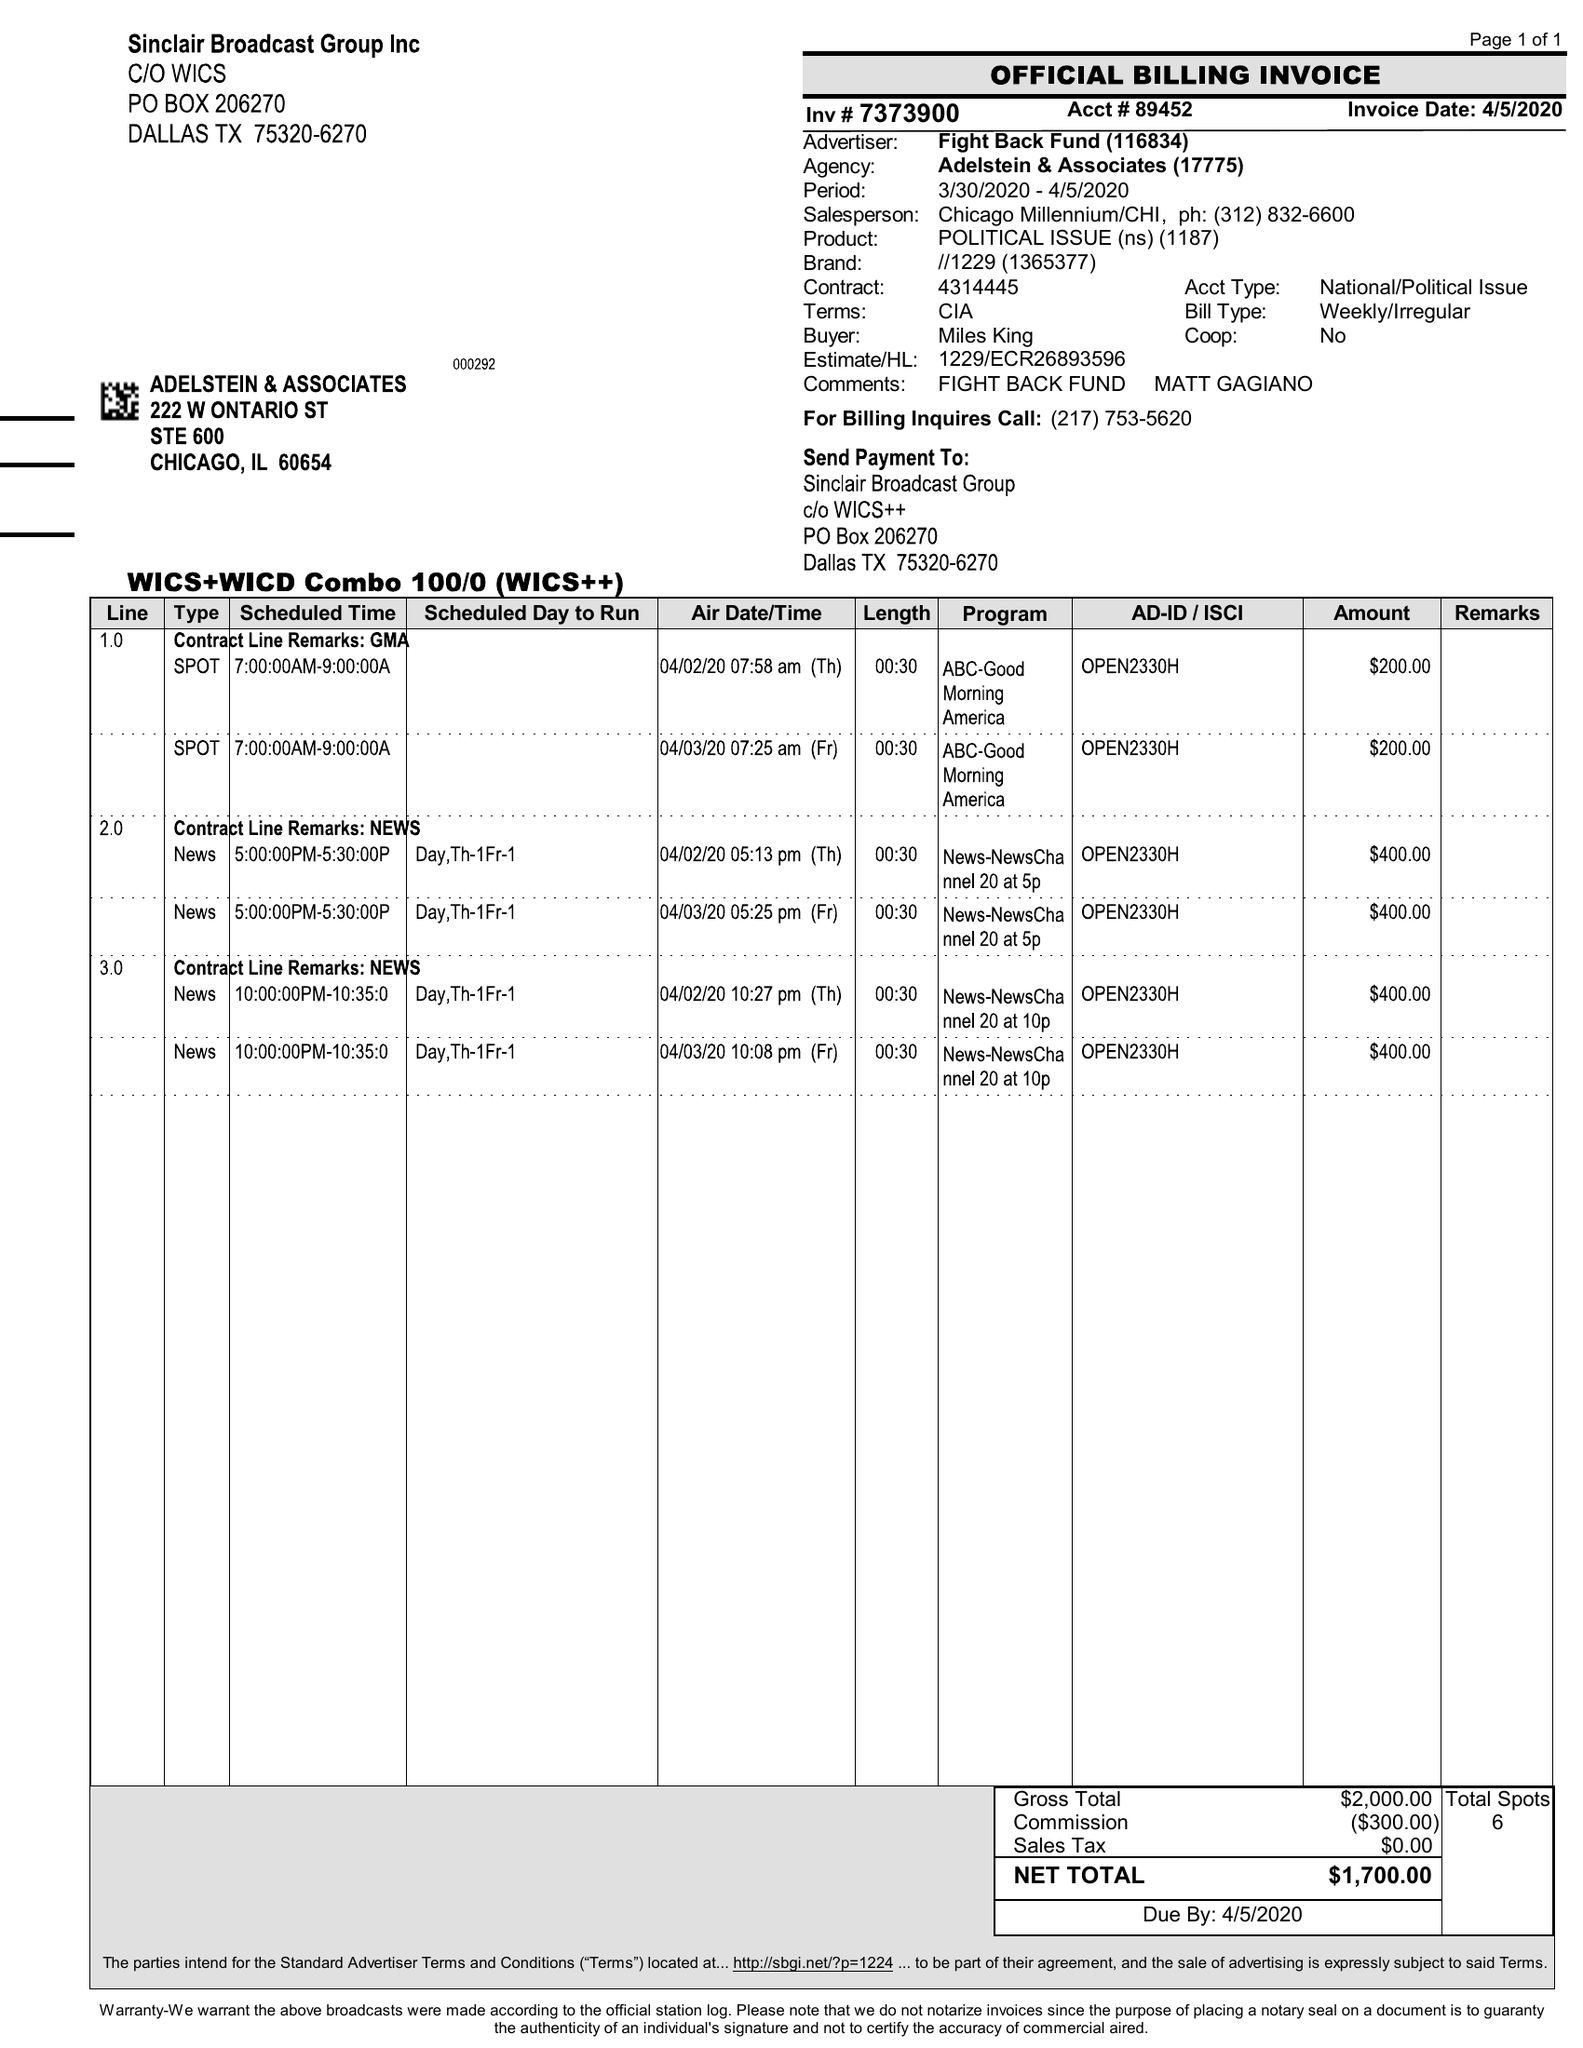What is the value for the gross_amount?
Answer the question using a single word or phrase. 2000.00 